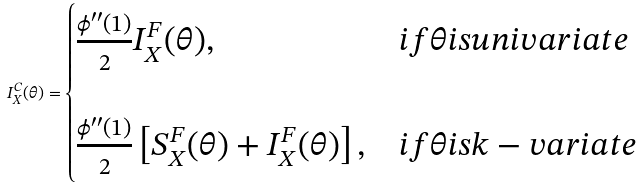<formula> <loc_0><loc_0><loc_500><loc_500>I _ { X } ^ { C } ( \theta ) = \begin{cases} { \frac { { \phi } ^ { \prime \prime } ( 1 ) } { 2 } I _ { X } ^ { F } ( \theta ) , } & { i f \theta i s u n i v a r i a t e } \\ \\ { \frac { { \phi } ^ { \prime \prime } ( 1 ) } { 2 } \left [ { S _ { X } ^ { F } ( \theta ) + I _ { X } ^ { F } ( \theta ) } \right ] , } & { i f \theta i s k - v a r i a t e } \\ \end{cases}</formula> 